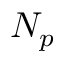Convert formula to latex. <formula><loc_0><loc_0><loc_500><loc_500>N _ { p }</formula> 